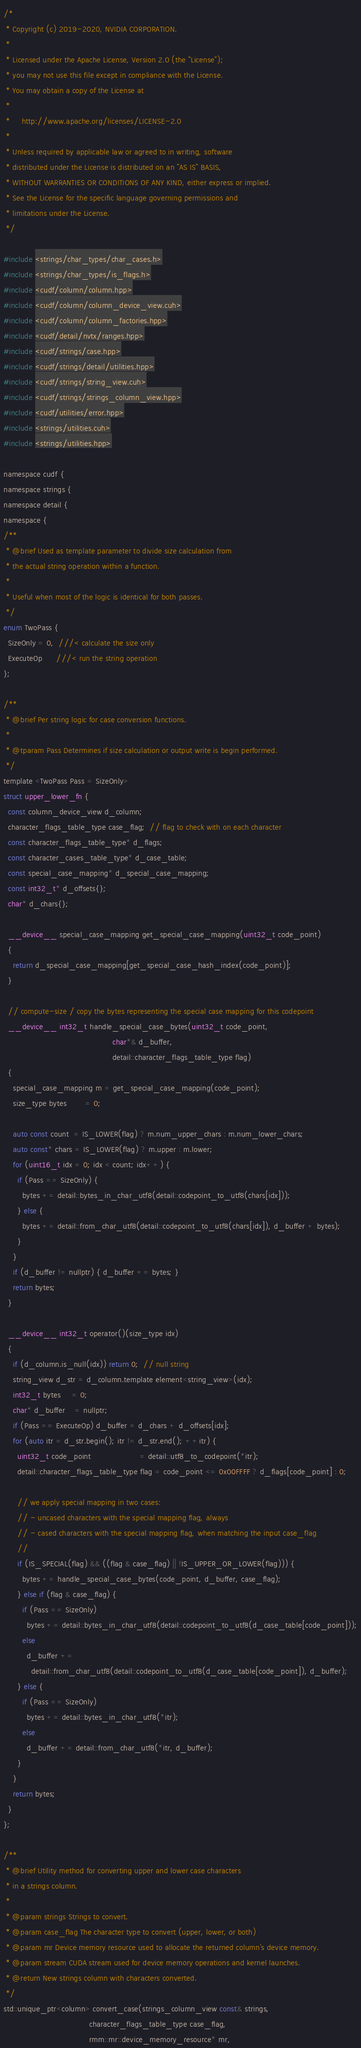Convert code to text. <code><loc_0><loc_0><loc_500><loc_500><_Cuda_>/*
 * Copyright (c) 2019-2020, NVIDIA CORPORATION.
 *
 * Licensed under the Apache License, Version 2.0 (the "License");
 * you may not use this file except in compliance with the License.
 * You may obtain a copy of the License at
 *
 *     http://www.apache.org/licenses/LICENSE-2.0
 *
 * Unless required by applicable law or agreed to in writing, software
 * distributed under the License is distributed on an "AS IS" BASIS,
 * WITHOUT WARRANTIES OR CONDITIONS OF ANY KIND, either express or implied.
 * See the License for the specific language governing permissions and
 * limitations under the License.
 */

#include <strings/char_types/char_cases.h>
#include <strings/char_types/is_flags.h>
#include <cudf/column/column.hpp>
#include <cudf/column/column_device_view.cuh>
#include <cudf/column/column_factories.hpp>
#include <cudf/detail/nvtx/ranges.hpp>
#include <cudf/strings/case.hpp>
#include <cudf/strings/detail/utilities.hpp>
#include <cudf/strings/string_view.cuh>
#include <cudf/strings/strings_column_view.hpp>
#include <cudf/utilities/error.hpp>
#include <strings/utilities.cuh>
#include <strings/utilities.hpp>

namespace cudf {
namespace strings {
namespace detail {
namespace {
/**
 * @brief Used as template parameter to divide size calculation from
 * the actual string operation within a function.
 *
 * Useful when most of the logic is identical for both passes.
 */
enum TwoPass {
  SizeOnly = 0,  ///< calculate the size only
  ExecuteOp      ///< run the string operation
};

/**
 * @brief Per string logic for case conversion functions.
 *
 * @tparam Pass Determines if size calculation or output write is begin performed.
 */
template <TwoPass Pass = SizeOnly>
struct upper_lower_fn {
  const column_device_view d_column;
  character_flags_table_type case_flag;  // flag to check with on each character
  const character_flags_table_type* d_flags;
  const character_cases_table_type* d_case_table;
  const special_case_mapping* d_special_case_mapping;
  const int32_t* d_offsets{};
  char* d_chars{};

  __device__ special_case_mapping get_special_case_mapping(uint32_t code_point)
  {
    return d_special_case_mapping[get_special_case_hash_index(code_point)];
  }

  // compute-size / copy the bytes representing the special case mapping for this codepoint
  __device__ int32_t handle_special_case_bytes(uint32_t code_point,
                                               char*& d_buffer,
                                               detail::character_flags_table_type flag)
  {
    special_case_mapping m = get_special_case_mapping(code_point);
    size_type bytes        = 0;

    auto const count  = IS_LOWER(flag) ? m.num_upper_chars : m.num_lower_chars;
    auto const* chars = IS_LOWER(flag) ? m.upper : m.lower;
    for (uint16_t idx = 0; idx < count; idx++) {
      if (Pass == SizeOnly) {
        bytes += detail::bytes_in_char_utf8(detail::codepoint_to_utf8(chars[idx]));
      } else {
        bytes += detail::from_char_utf8(detail::codepoint_to_utf8(chars[idx]), d_buffer + bytes);
      }
    }
    if (d_buffer != nullptr) { d_buffer += bytes; }
    return bytes;
  }

  __device__ int32_t operator()(size_type idx)
  {
    if (d_column.is_null(idx)) return 0;  // null string
    string_view d_str = d_column.template element<string_view>(idx);
    int32_t bytes     = 0;
    char* d_buffer    = nullptr;
    if (Pass == ExecuteOp) d_buffer = d_chars + d_offsets[idx];
    for (auto itr = d_str.begin(); itr != d_str.end(); ++itr) {
      uint32_t code_point                     = detail::utf8_to_codepoint(*itr);
      detail::character_flags_table_type flag = code_point <= 0x00FFFF ? d_flags[code_point] : 0;

      // we apply special mapping in two cases:
      // - uncased characters with the special mapping flag, always
      // - cased characters with the special mapping flag, when matching the input case_flag
      //
      if (IS_SPECIAL(flag) && ((flag & case_flag) || !IS_UPPER_OR_LOWER(flag))) {
        bytes += handle_special_case_bytes(code_point, d_buffer, case_flag);
      } else if (flag & case_flag) {
        if (Pass == SizeOnly)
          bytes += detail::bytes_in_char_utf8(detail::codepoint_to_utf8(d_case_table[code_point]));
        else
          d_buffer +=
            detail::from_char_utf8(detail::codepoint_to_utf8(d_case_table[code_point]), d_buffer);
      } else {
        if (Pass == SizeOnly)
          bytes += detail::bytes_in_char_utf8(*itr);
        else
          d_buffer += detail::from_char_utf8(*itr, d_buffer);
      }
    }
    return bytes;
  }
};

/**
 * @brief Utility method for converting upper and lower case characters
 * in a strings column.
 *
 * @param strings Strings to convert.
 * @param case_flag The character type to convert (upper, lower, or both)
 * @param mr Device memory resource used to allocate the returned column's device memory.
 * @param stream CUDA stream used for device memory operations and kernel launches.
 * @return New strings column with characters converted.
 */
std::unique_ptr<column> convert_case(strings_column_view const& strings,
                                     character_flags_table_type case_flag,
                                     rmm::mr::device_memory_resource* mr,</code> 